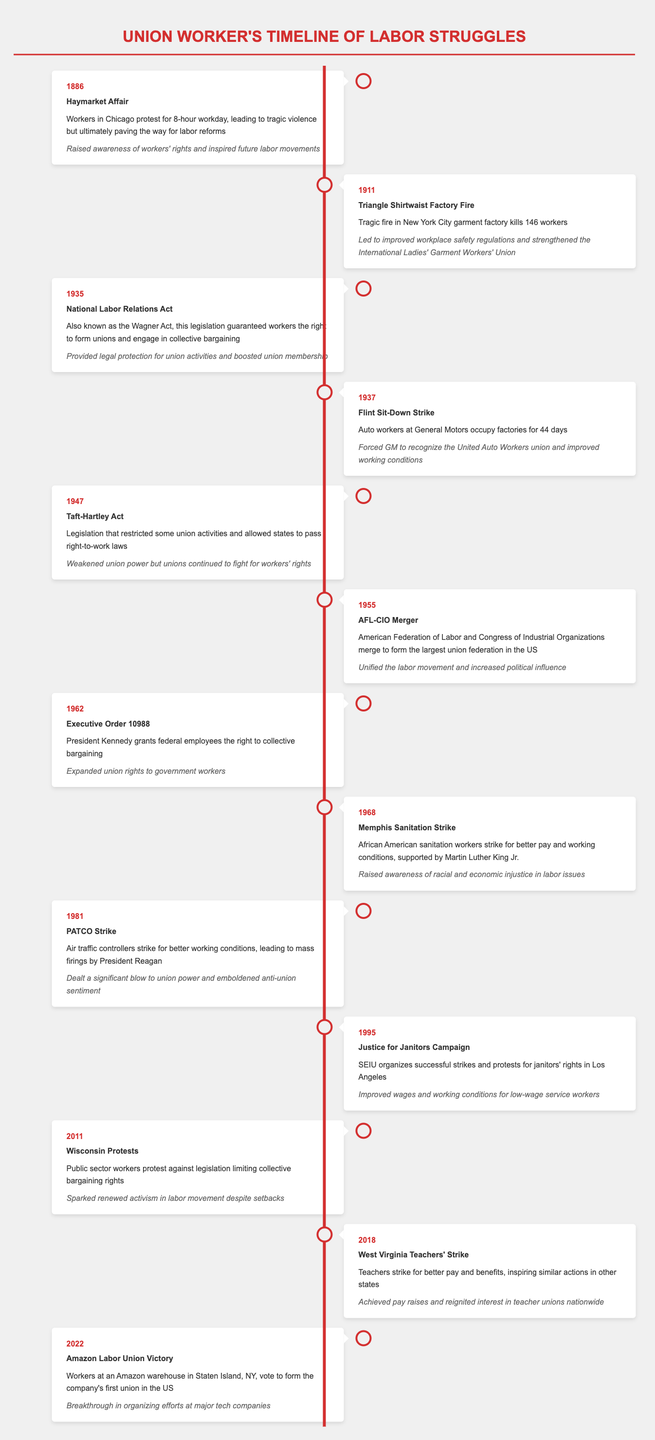What year did the Flint Sit-Down Strike occur? According to the table, the event "Flint Sit-Down Strike" is listed under the year 1937.
Answer: 1937 What impact did the Triangle Shirtwaist Factory Fire have? The event "Triangle Shirtwaist Factory Fire" mentions that it led to improved workplace safety regulations and strengthened the International Ladies' Garment Workers' Union.
Answer: Led to improved workplace safety regulations and strengthened the International Ladies' Garment Workers' Union Which event occurred between 1960 and 1970? By scanning the table, the "Memphis Sanitation Strike" in 1968 is the only event listed in that decade.
Answer: Memphis Sanitation Strike Was the National Labor Relations Act enacted before the Taft-Hartley Act? The National Labor Relations Act is in 1935 and the Taft-Hartley Act is in 1947, so the National Labor Relations Act occurred before the Taft-Hartley Act.
Answer: Yes How many years apart were the Haymarket Affair and the Amazon Labor Union Victory? The Haymarket Affair was in 1886 and the Amazon Labor Union Victory was in 2022, so the difference is 2022 - 1886 = 136 years.
Answer: 136 years In what year did teachers in West Virginia strike? The event "West Virginia Teachers' Strike" is listed under the year 2018.
Answer: 2018 Did the PATCO Strike improve labor relations in the U.S.? The table states that the PATCO Strike "dealt a significant blow to union power and emboldened anti-union sentiment," indicating it did not improve labor relations.
Answer: No Which event was connected to President Kennedy? The "Executive Order 10988" is the event where President Kennedy granted federal employees the right to collective bargaining.
Answer: Executive Order 10988 What was the impact of the Wisconsin Protests in 2011? The table notes that the Wisconsin Protests sparked renewed activism in the labor movement despite setbacks.
Answer: Sparked renewed activism in labor movement 